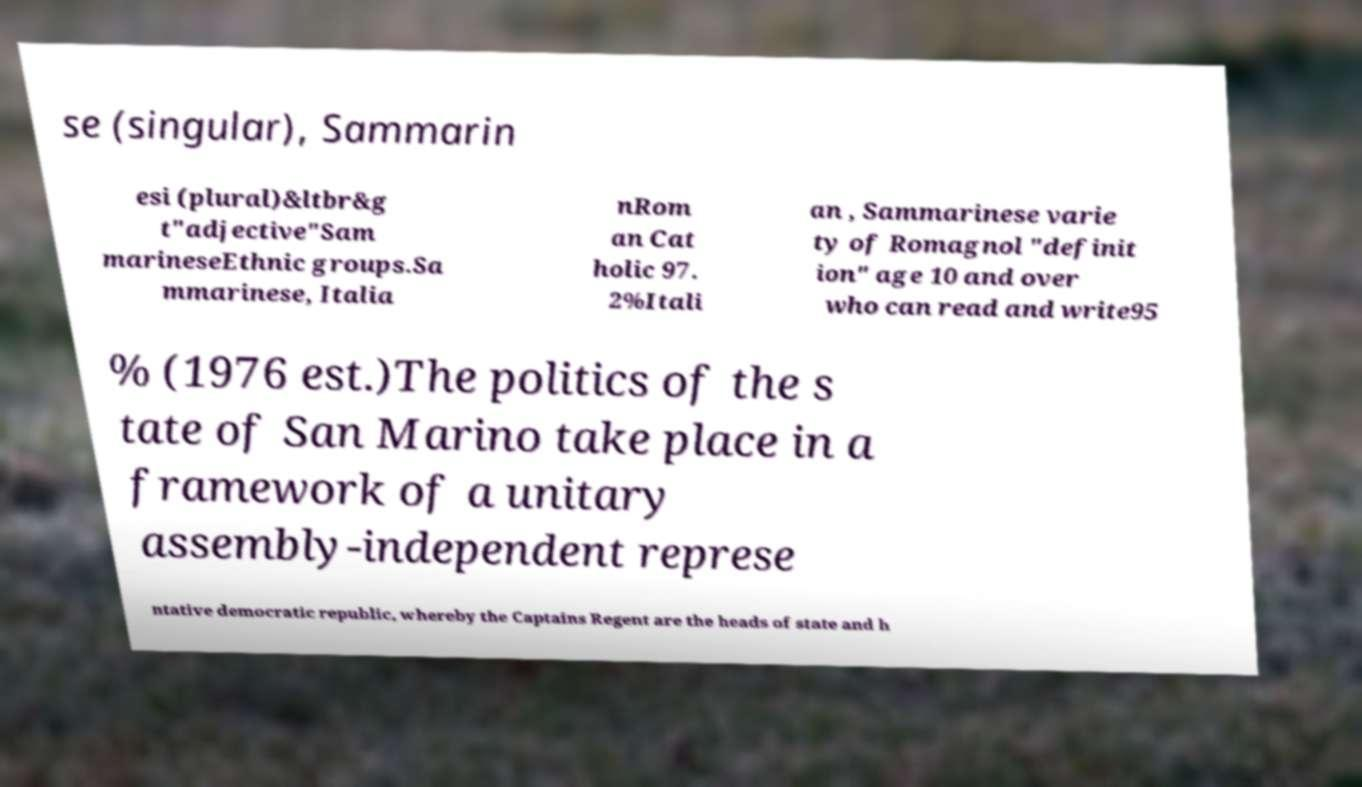Can you read and provide the text displayed in the image?This photo seems to have some interesting text. Can you extract and type it out for me? se (singular), Sammarin esi (plural)&ltbr&g t"adjective"Sam marineseEthnic groups.Sa mmarinese, Italia nRom an Cat holic 97. 2%Itali an , Sammarinese varie ty of Romagnol "definit ion" age 10 and over who can read and write95 % (1976 est.)The politics of the s tate of San Marino take place in a framework of a unitary assembly-independent represe ntative democratic republic, whereby the Captains Regent are the heads of state and h 